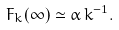Convert formula to latex. <formula><loc_0><loc_0><loc_500><loc_500>F _ { k } ( \infty ) \simeq \alpha \, k ^ { - 1 } .</formula> 